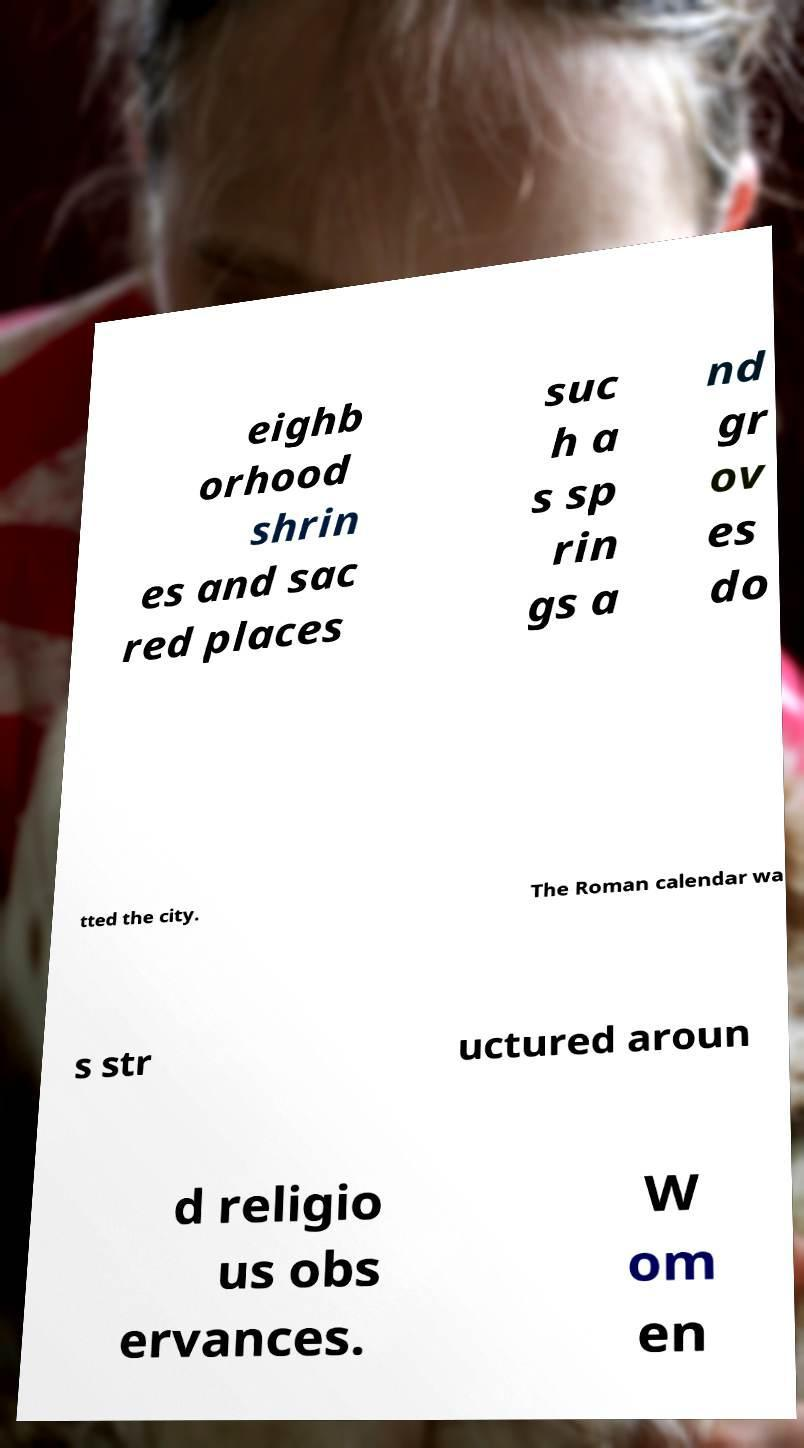Can you read and provide the text displayed in the image?This photo seems to have some interesting text. Can you extract and type it out for me? eighb orhood shrin es and sac red places suc h a s sp rin gs a nd gr ov es do tted the city. The Roman calendar wa s str uctured aroun d religio us obs ervances. W om en 